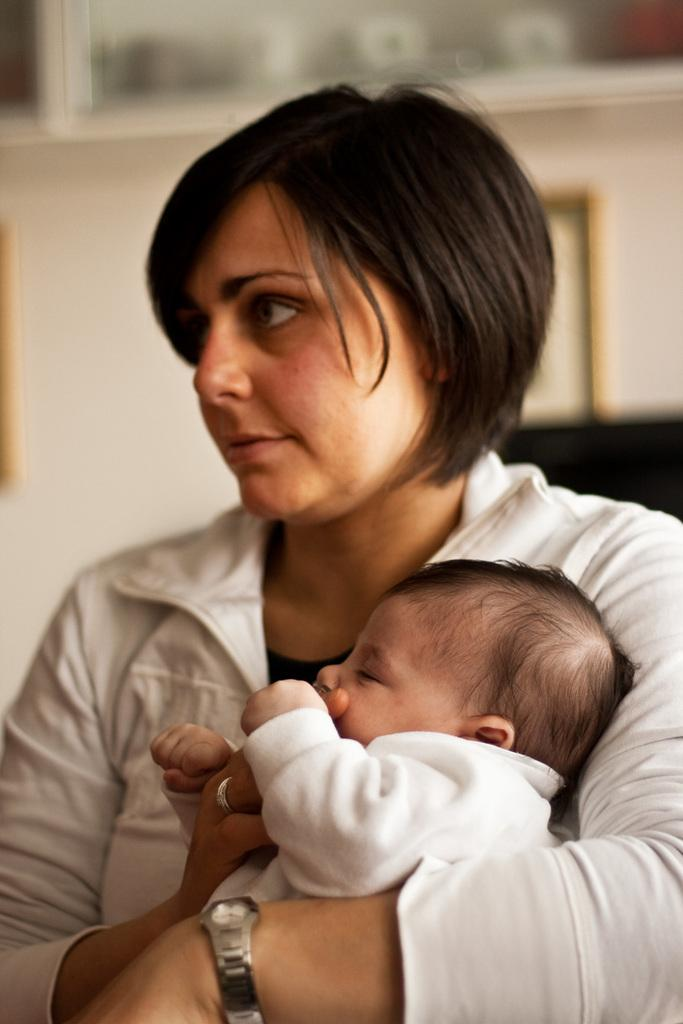Who is the main subject in the image? There is a lady in the image. What is the lady wearing? The lady is wearing a white dress and a silver ring. She is also wearing a watch. What is the lady holding in the image? The lady is holding a baby. Can you describe the background of the image? The background of the image is blurred. What type of food is the lady eating in the image? There is no food present in the image, so it cannot be determined what the lady might be eating. 